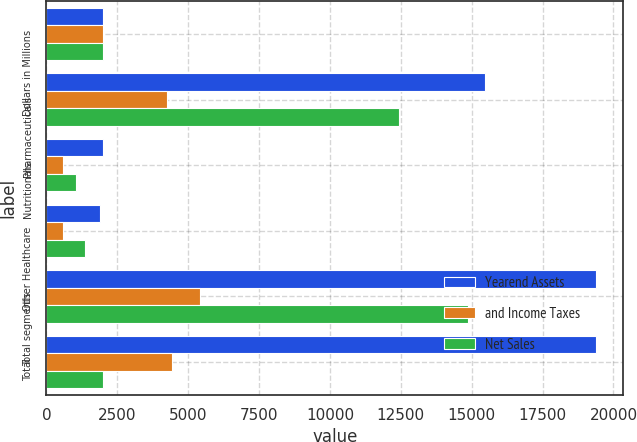Convert chart to OTSL. <chart><loc_0><loc_0><loc_500><loc_500><stacked_bar_chart><ecel><fcel>Dollars in Millions<fcel>Pharmaceuticals<fcel>Nutritionals<fcel>Other Healthcare<fcel>Total segments<fcel>Total<nl><fcel>Yearend Assets<fcel>2004<fcel>15482<fcel>2001<fcel>1897<fcel>19380<fcel>19380<nl><fcel>and Income Taxes<fcel>2004<fcel>4257<fcel>586<fcel>573<fcel>5416<fcel>4418<nl><fcel>Net Sales<fcel>2004<fcel>12436<fcel>1055<fcel>1368<fcel>14859<fcel>2004<nl></chart> 